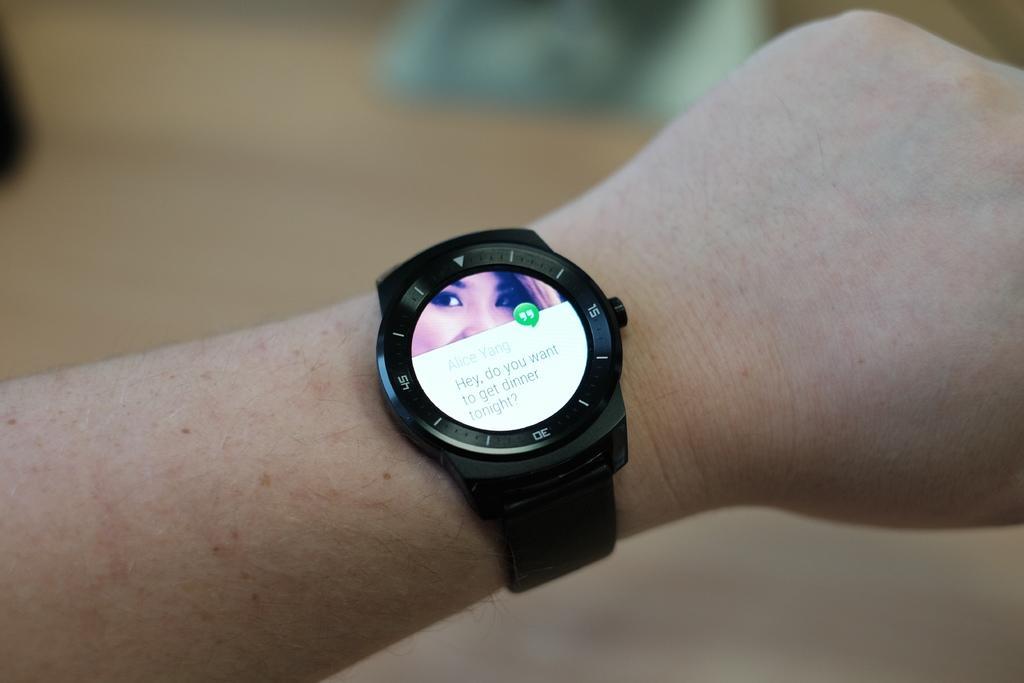Describe this image in one or two sentences. In this picture we can see a persons hand wearing a watch and there is one popup hangout message stating "alice yang - Hey do you want to get dinner tonight". On the backside of the popup message, there is a picture of the women. 